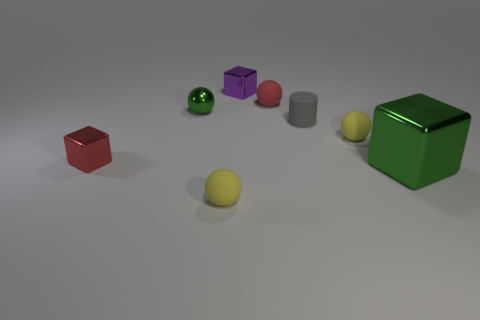There is a metallic block that is the same color as the shiny sphere; what is its size?
Ensure brevity in your answer.  Large. What shape is the small thing that is the same color as the large object?
Make the answer very short. Sphere. Is there any other thing that has the same material as the small purple object?
Your response must be concise. Yes. Is the number of small cubes in front of the big green thing less than the number of red things?
Your answer should be compact. Yes. Are there more big green metallic cubes than metal objects?
Your answer should be compact. No. Is there a matte cylinder that is on the right side of the tiny yellow matte object that is to the right of the yellow ball in front of the large green block?
Make the answer very short. No. How many other things are the same size as the red matte object?
Provide a short and direct response. 6. There is a matte cylinder; are there any small green metallic things in front of it?
Offer a terse response. No. There is a metallic ball; is it the same color as the small metal object behind the green ball?
Offer a very short reply. No. What is the color of the shiny sphere that is behind the tiny red object on the left side of the matte object in front of the green metal block?
Your answer should be very brief. Green. 